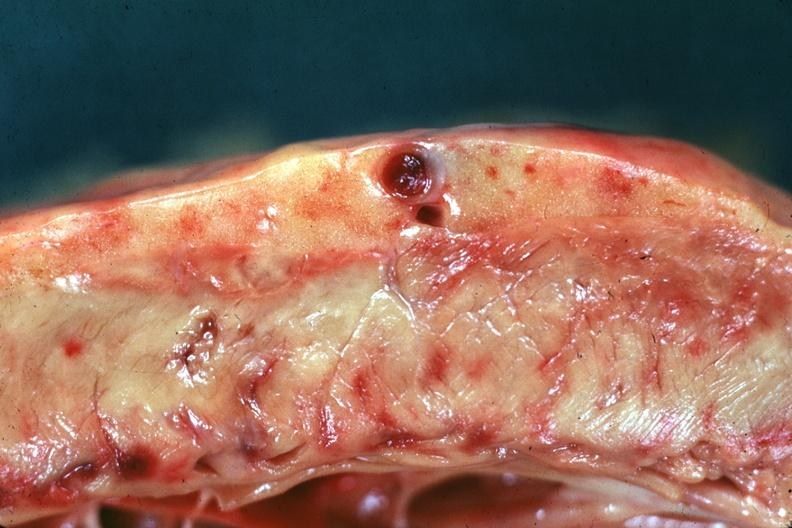does this image show no hyperplasia?
Answer the question using a single word or phrase. Yes 